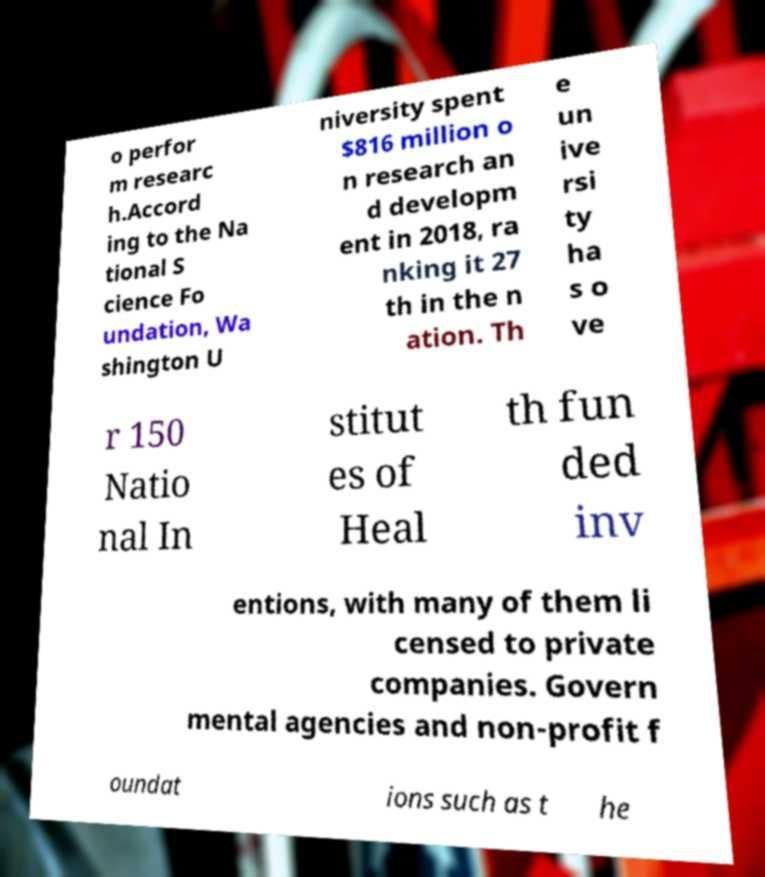Please identify and transcribe the text found in this image. o perfor m researc h.Accord ing to the Na tional S cience Fo undation, Wa shington U niversity spent $816 million o n research an d developm ent in 2018, ra nking it 27 th in the n ation. Th e un ive rsi ty ha s o ve r 150 Natio nal In stitut es of Heal th fun ded inv entions, with many of them li censed to private companies. Govern mental agencies and non-profit f oundat ions such as t he 